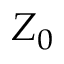Convert formula to latex. <formula><loc_0><loc_0><loc_500><loc_500>Z _ { 0 }</formula> 